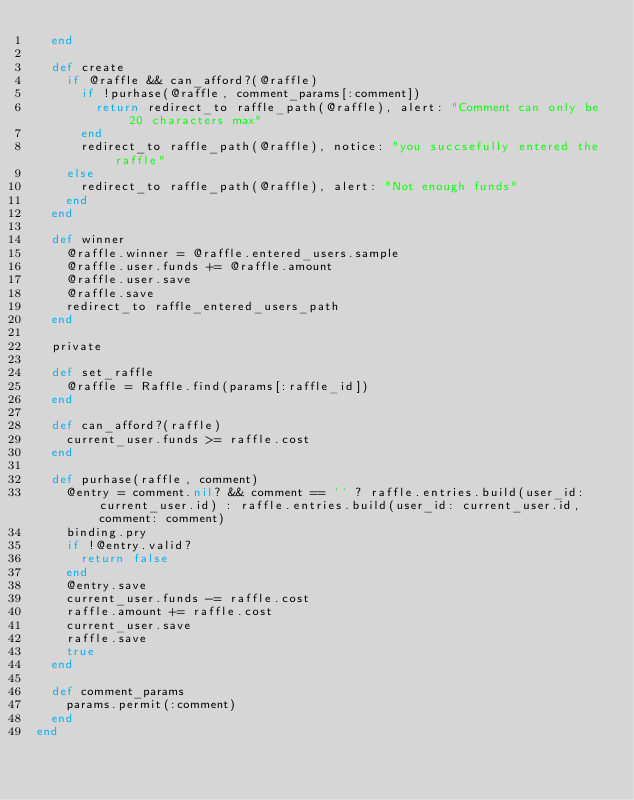Convert code to text. <code><loc_0><loc_0><loc_500><loc_500><_Ruby_>  end

  def create 
    if @raffle && can_afford?(@raffle)
      if !purhase(@raffle, comment_params[:comment])
        return redirect_to raffle_path(@raffle), alert: "Comment can only be 20 characters max"
      end 
      redirect_to raffle_path(@raffle), notice: "you succsefully entered the raffle"
    else
      redirect_to raffle_path(@raffle), alert: "Not enough funds"
    end 
  end

  def winner 
    @raffle.winner = @raffle.entered_users.sample
    @raffle.user.funds += @raffle.amount
    @raffle.user.save
    @raffle.save
    redirect_to raffle_entered_users_path
  end

  private

  def set_raffle
    @raffle = Raffle.find(params[:raffle_id])
  end

  def can_afford?(raffle)
    current_user.funds >= raffle.cost 
  end
  
  def purhase(raffle, comment)
    @entry = comment.nil? && comment == '' ? raffle.entries.build(user_id: current_user.id) : raffle.entries.build(user_id: current_user.id,comment: comment) 
    binding.pry
    if !@entry.valid?
      return false
    end
    @entry.save
    current_user.funds -= raffle.cost
    raffle.amount += raffle.cost
    current_user.save
    raffle.save
    true
  end

  def comment_params 
    params.permit(:comment)
  end
end </code> 